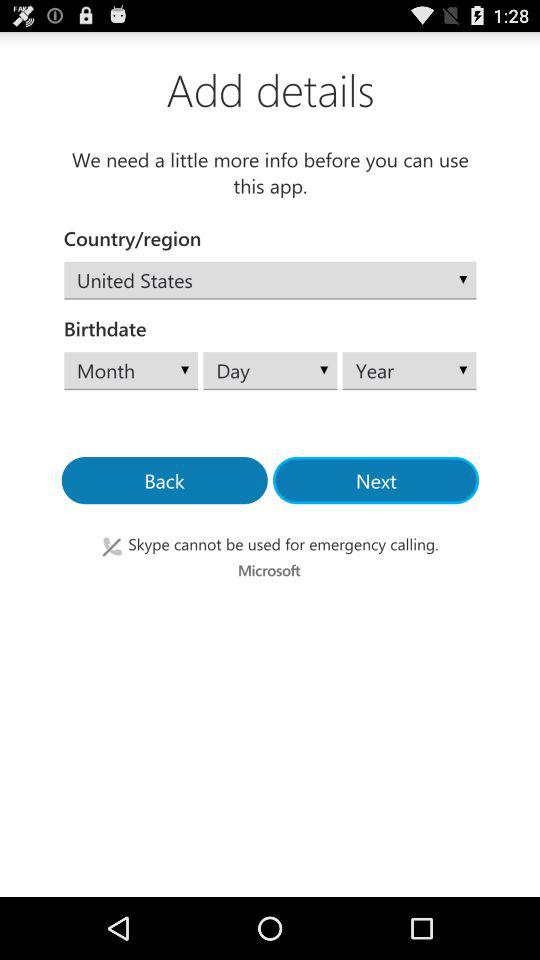What is the name of the country? The name of the country is the United States. 